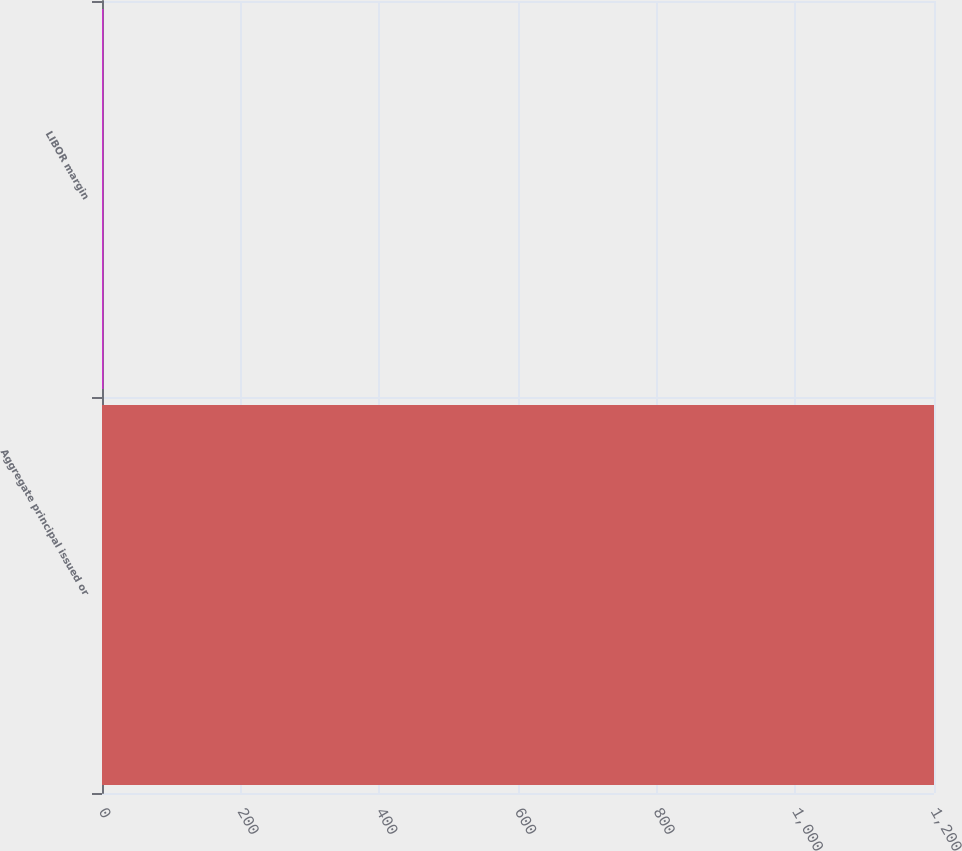Convert chart. <chart><loc_0><loc_0><loc_500><loc_500><bar_chart><fcel>Aggregate principal issued or<fcel>LIBOR margin<nl><fcel>1200<fcel>2.25<nl></chart> 